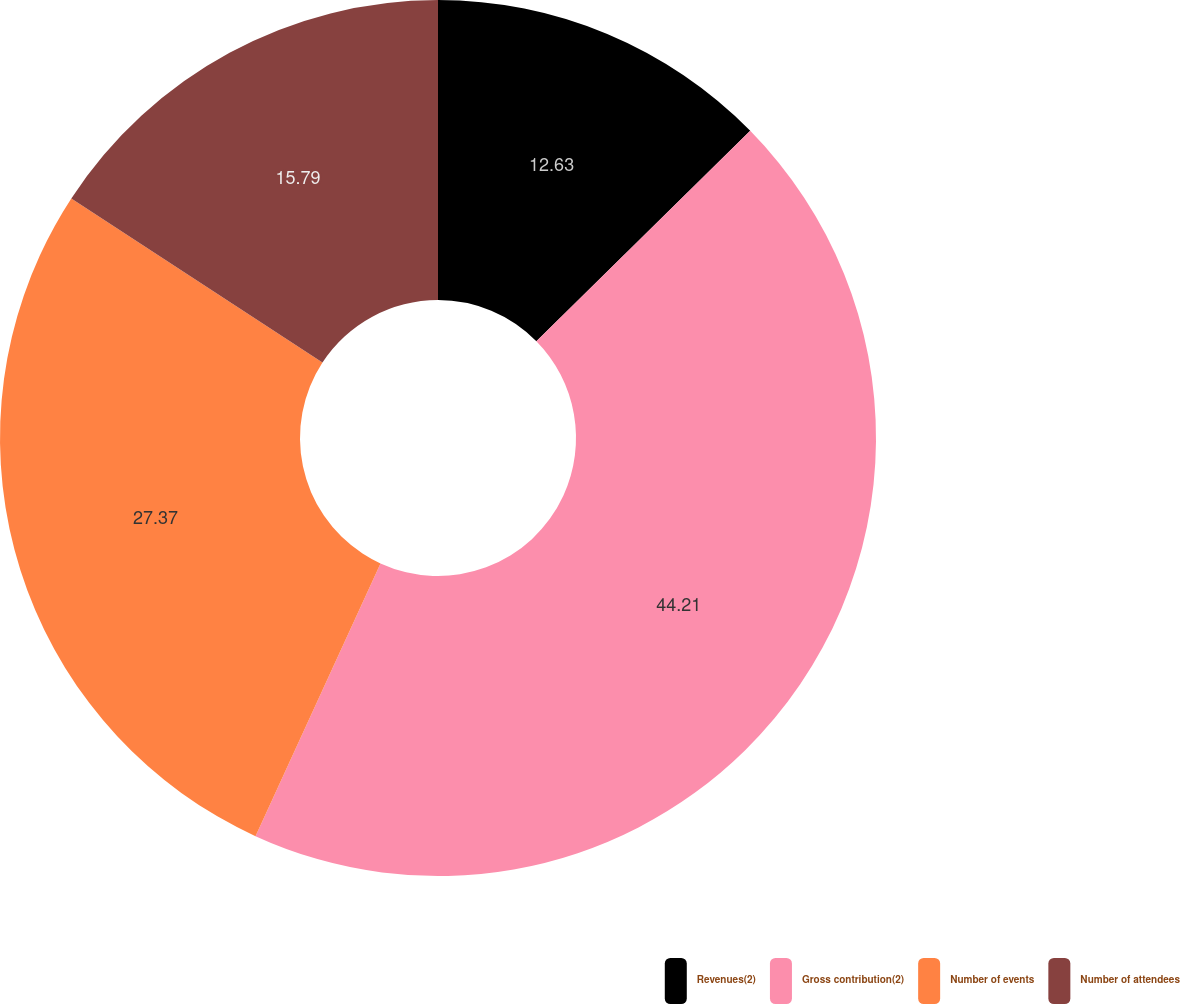<chart> <loc_0><loc_0><loc_500><loc_500><pie_chart><fcel>Revenues(2)<fcel>Gross contribution(2)<fcel>Number of events<fcel>Number of attendees<nl><fcel>12.63%<fcel>44.21%<fcel>27.37%<fcel>15.79%<nl></chart> 